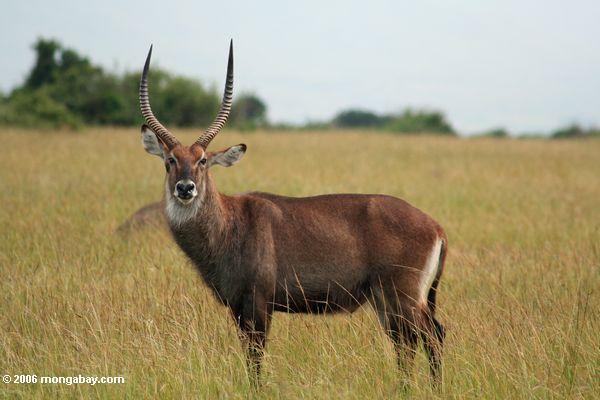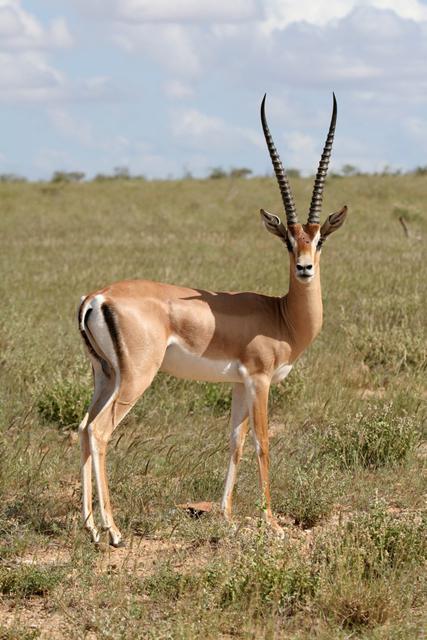The first image is the image on the left, the second image is the image on the right. For the images shown, is this caption "The horned animal on the left faces the camera directly, although its body is in full profile." true? Answer yes or no. Yes. 